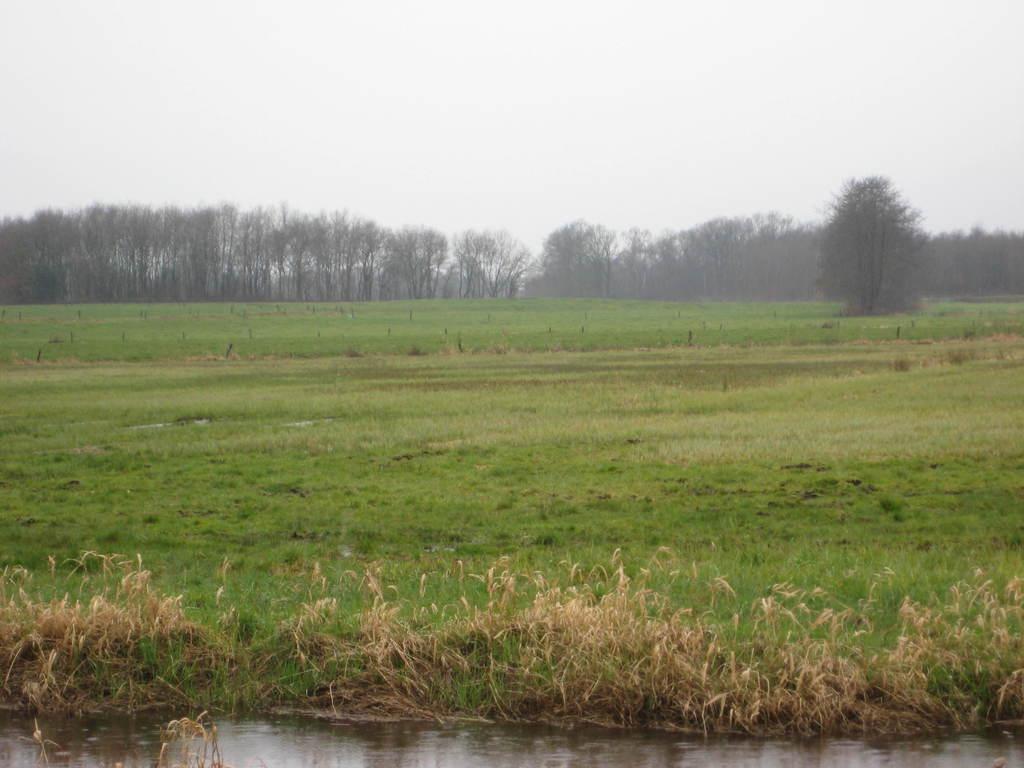In one or two sentences, can you explain what this image depicts? This is an outside view. Here I can see the grass in green color. At the bottom of the image I can see the water. In the background there are some trees. On the top of the image I can see the sky. 